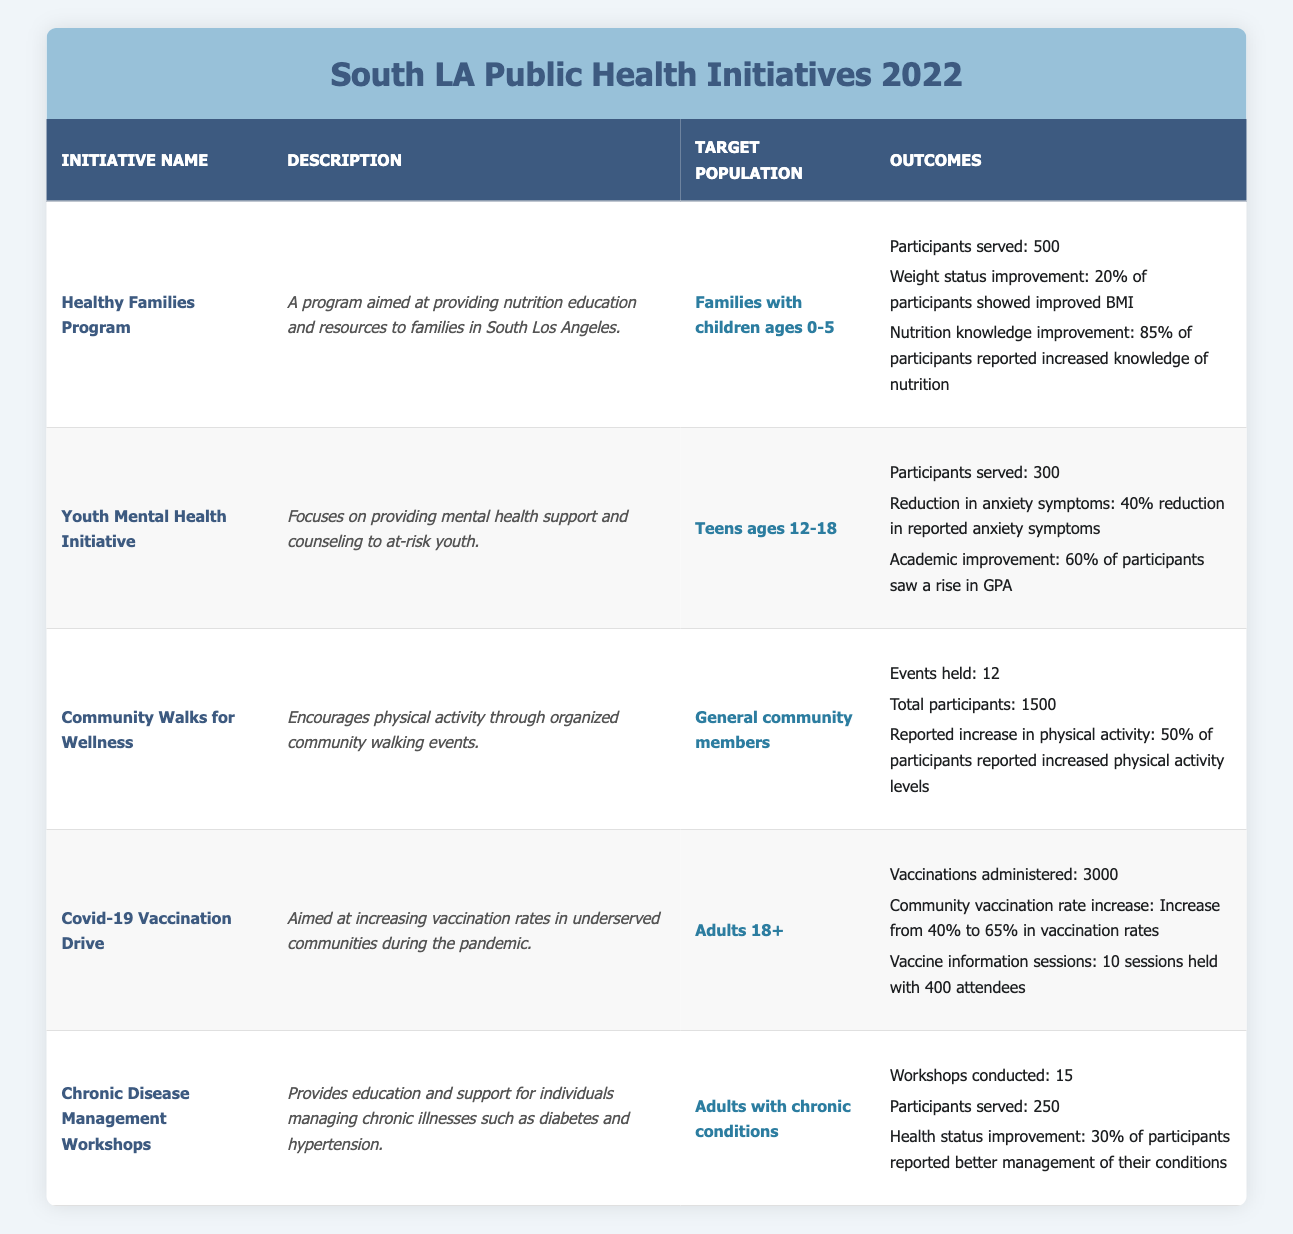What is the total number of participants served across all initiatives? To find the total number of participants served, we add the participants served from each initiative: 500 (Healthy Families Program) + 300 (Youth Mental Health Initiative) + 1500 (Community Walks for Wellness) + 3000 (Covid-19 Vaccination Drive) + 250 (Chronic Disease Management Workshops) = 4550 participants.
Answer: 4550 Which initiative had the highest number of participants served? The initiative with the highest number of participants served is the Covid-19 Vaccination Drive, which served 3000 participants.
Answer: Covid-19 Vaccination Drive What percentage of participants in the Youth Mental Health Initiative saw a rise in GPA? According to the data, 60% of participants in the Youth Mental Health Initiative saw a rise in GPA.
Answer: 60% Did the Community Walks for Wellness have more participants than the Youth Mental Health Initiative? Yes, the Community Walks for Wellness had 1500 participants, which is more than the Youth Mental Health Initiative that served 300 participants.
Answer: Yes What was the improvement in community vaccination rates due to the Covid-19 Vaccination Drive? The improvement in community vaccination rates was an increase from 40% to 65%, which represents a 25 percentage point increase.
Answer: 25 percentage points How many workshops were conducted in total within the Chronic Disease Management Workshops initiative? The Chronic Disease Management Workshops initiative conducted a total of 15 workshops.
Answer: 15 Is it true that 30% of participants in the Chronic Disease Management Workshops reported better management of their conditions? Yes, it is true that 30% of participants in the Chronic Disease Management Workshops reported better management of their conditions.
Answer: Yes What is the average number of participants served across all initiatives listed? To calculate the average, first add up the participants served: 500 + 300 + 1500 + 3000 + 250 = 4550. Then divide this total by the number of initiatives (5): 4550 / 5 = 910.
Answer: 910 Which initiative aimed specifically at families with children ages 0-5? The initiative aimed specifically at families with children ages 0-5 is the Healthy Families Program.
Answer: Healthy Families Program 